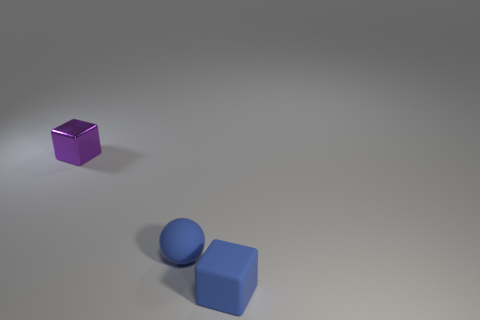What material is the tiny object that is the same color as the matte block?
Offer a terse response. Rubber. Is the shape of the small purple metallic object the same as the matte object in front of the small blue ball?
Make the answer very short. Yes. What is the shape of the small purple object?
Give a very brief answer. Cube. What is the material of the blue cube that is the same size as the purple thing?
Give a very brief answer. Rubber. Is there any other thing that has the same size as the blue ball?
Give a very brief answer. Yes. How many objects are either blue matte balls or things behind the blue rubber block?
Make the answer very short. 2. The thing that is made of the same material as the sphere is what size?
Provide a short and direct response. Small. The matte thing that is in front of the blue sphere that is behind the small blue cube is what shape?
Ensure brevity in your answer.  Cube. What size is the object that is both behind the blue block and in front of the metallic block?
Provide a succinct answer. Small. Is there a big yellow metallic object of the same shape as the purple shiny thing?
Offer a very short reply. No. 